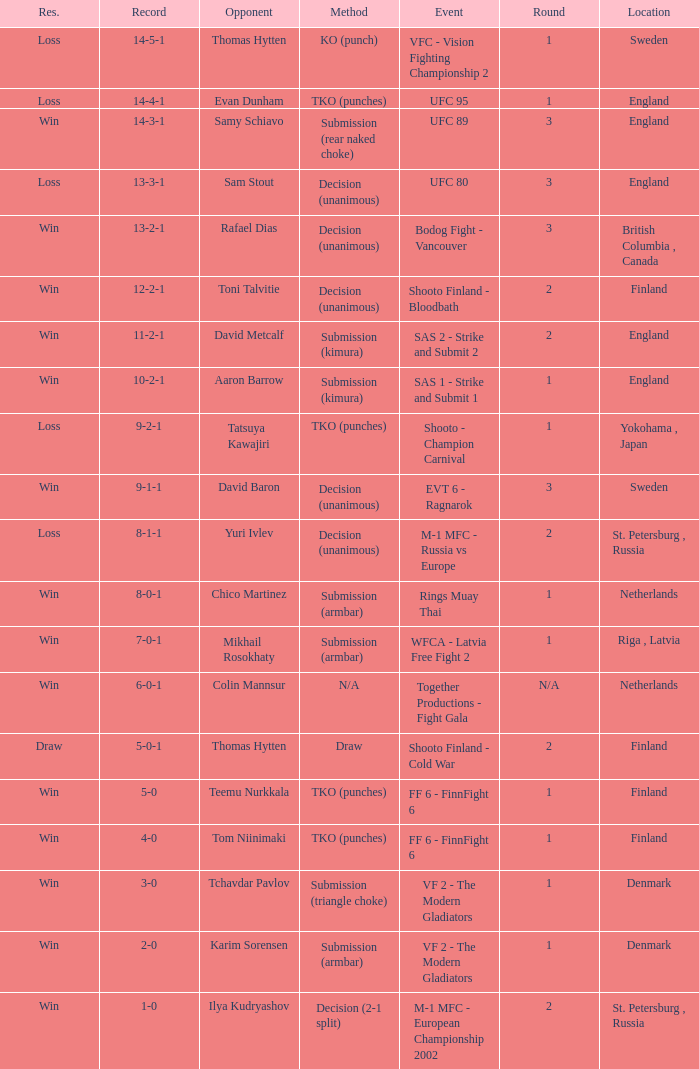What's the location when the record was 6-0-1? Netherlands. 